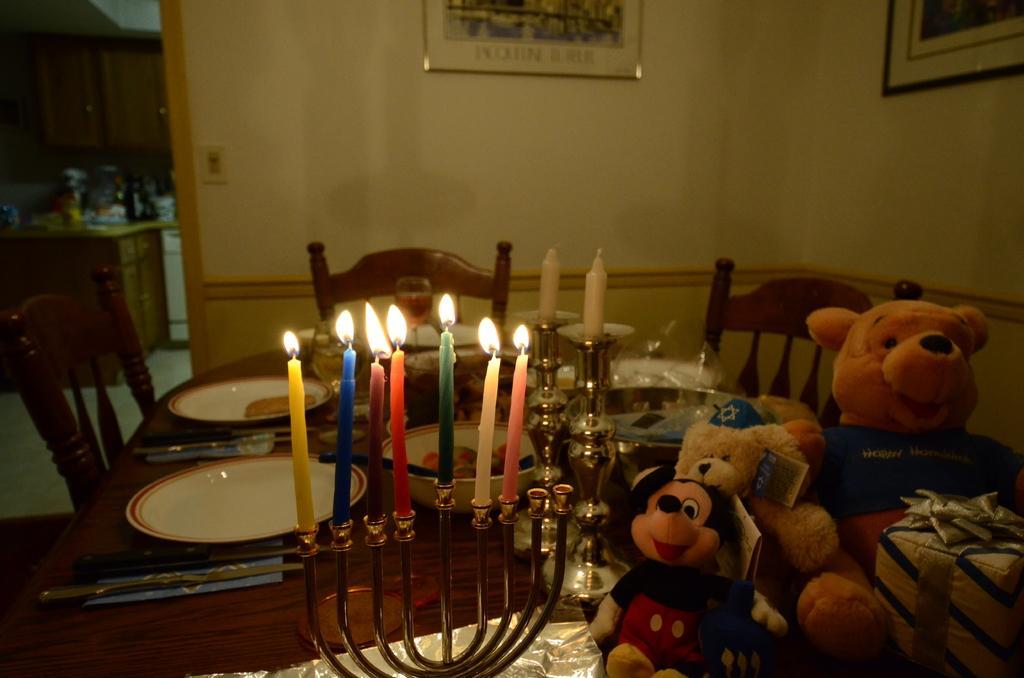Please provide a concise description of this image. In this image I see a table on which there are candles, soft toys, plates and glasses and I also see food in the bowl and i see 3 chairs. In the background I see the wall on which there are 2 photo frames and few things on the counter top. 